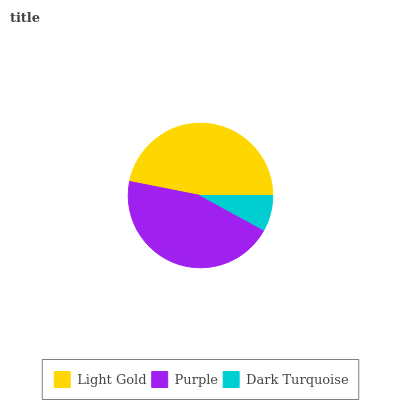Is Dark Turquoise the minimum?
Answer yes or no. Yes. Is Light Gold the maximum?
Answer yes or no. Yes. Is Purple the minimum?
Answer yes or no. No. Is Purple the maximum?
Answer yes or no. No. Is Light Gold greater than Purple?
Answer yes or no. Yes. Is Purple less than Light Gold?
Answer yes or no. Yes. Is Purple greater than Light Gold?
Answer yes or no. No. Is Light Gold less than Purple?
Answer yes or no. No. Is Purple the high median?
Answer yes or no. Yes. Is Purple the low median?
Answer yes or no. Yes. Is Light Gold the high median?
Answer yes or no. No. Is Light Gold the low median?
Answer yes or no. No. 